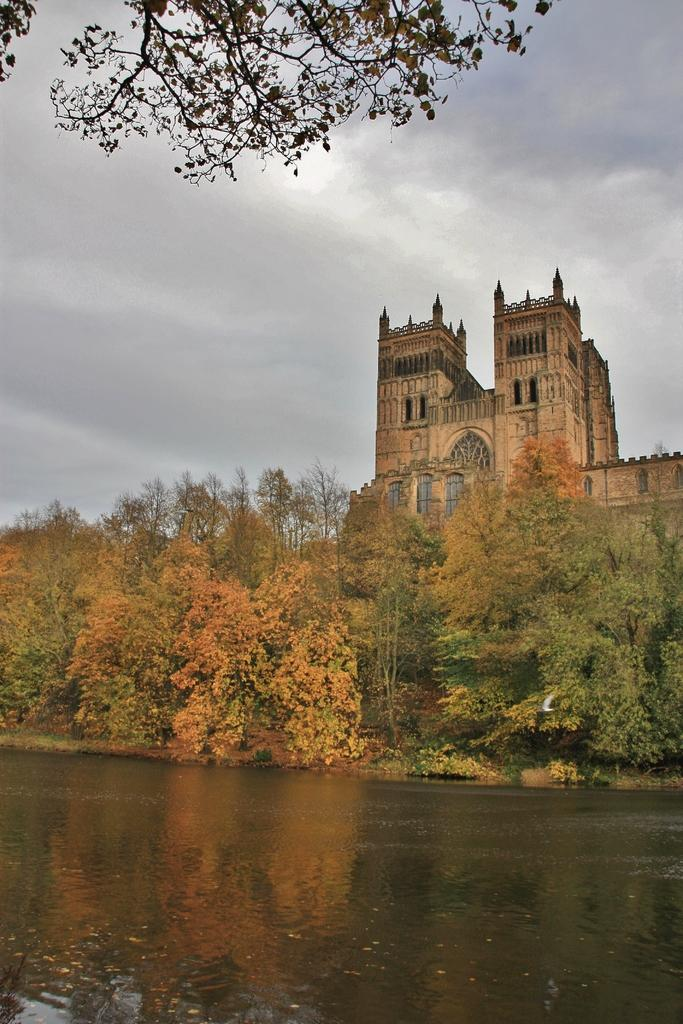What type of structure can be seen in the image? There is a building in the image. What other natural elements are present in the image? There are trees and water visible in the image. What is visible at the top of the image? The sky is visible at the top of the image. What can be observed in the sky? Clouds are present in the sky. How does the coach help the team in the image? There is no coach or team present in the image; it features a building, trees, sky, clouds, and water. 